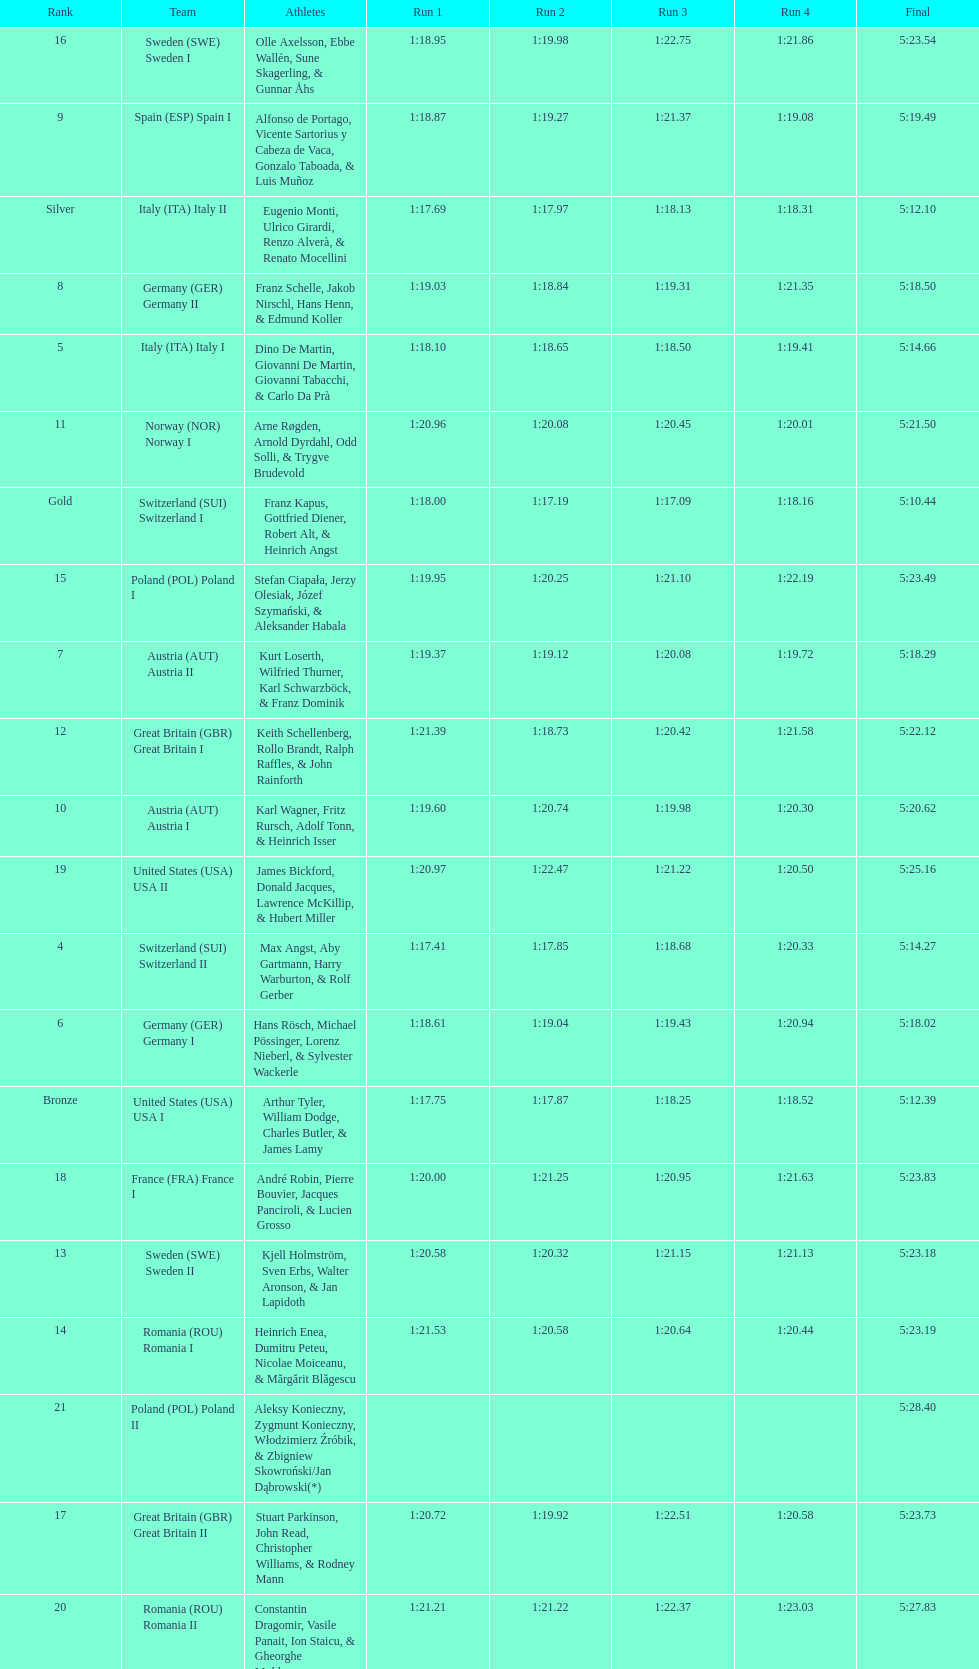How many teams did germany have? 2. 